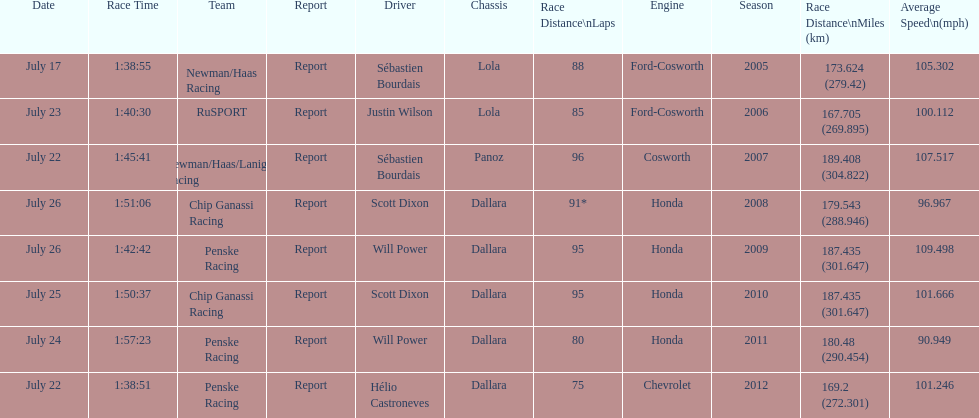How many flags other than france (the first flag) are represented? 3. 